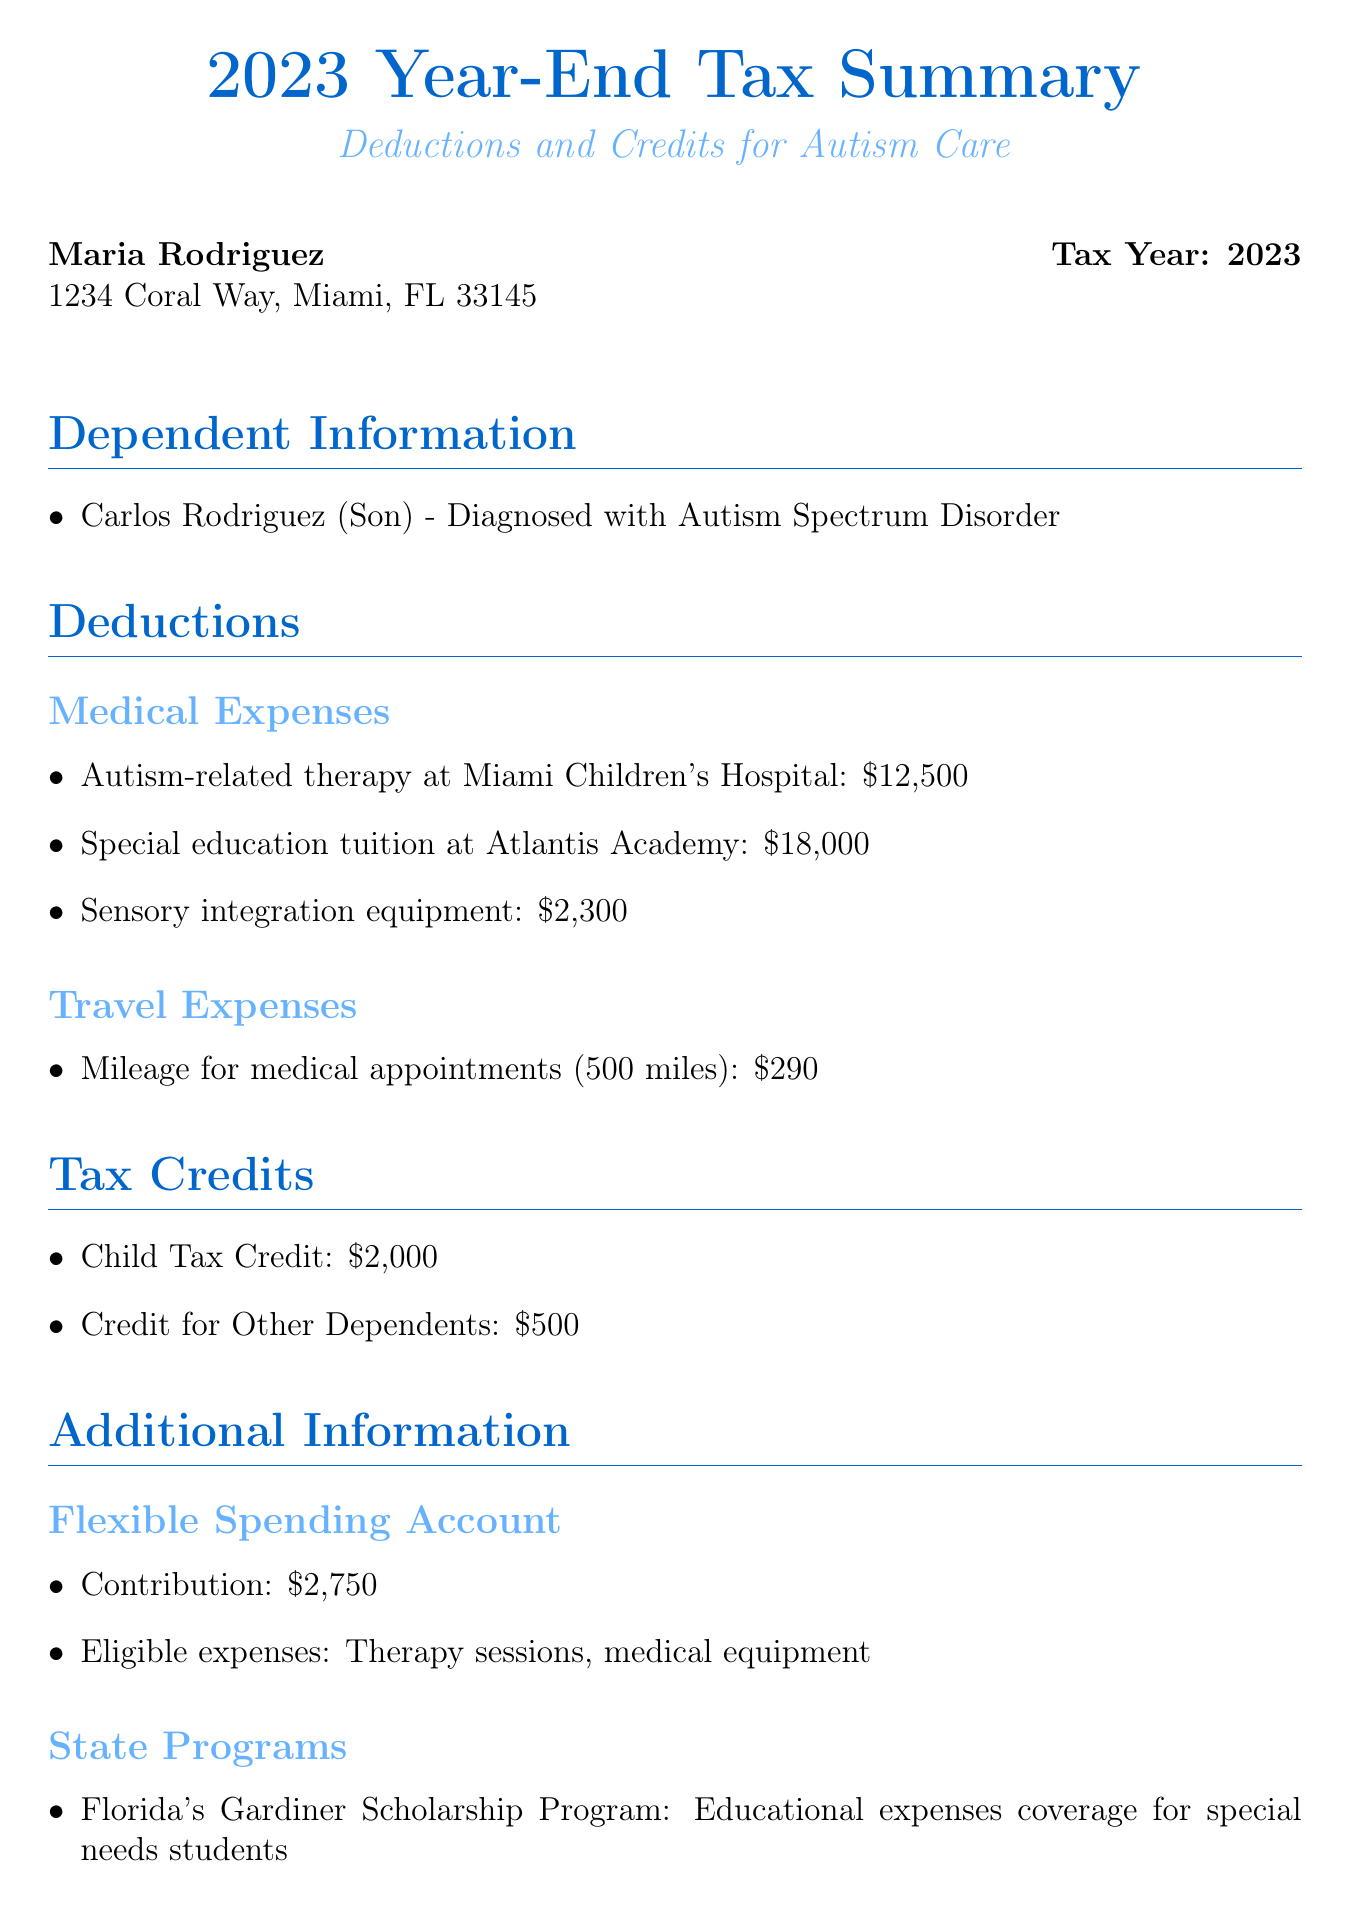What is the total amount spent on autism-related therapy? The total amount for autism-related therapy at Miami Children's Hospital is listed in the deductions section as $12,500.
Answer: $12,500 What is the contribution amount to the Flexible Spending Account? The document specifies the contribution to the Flexible Spending Account under Additional Information as $2,750.
Answer: $2,750 Who is the tax preparer? The tax preparer's name is provided at the bottom of the document, showing Johnson & Associates Tax Services.
Answer: Johnson & Associates Tax Services What is the diagnosis of Carlos Rodriguez? The diagnosis for Carlos Rodriguez is stated as Autism Spectrum Disorder in the Dependent Information section.
Answer: Autism Spectrum Disorder What is the total from the Travel Expenses category? The only item in the Travel Expenses is the mileage for medical appointments, which amounts to $290. This is the total.
Answer: $290 How much is the Child Tax Credit? The amount for the Child Tax Credit is noted in the Tax Credits section as $2,000.
Answer: $2,000 What educational expenses are covered under Florida's Gardiner Scholarship Program? The document mentions that it covers educational expenses for special needs students, specifically under State Programs.
Answer: Educational expenses for special needs students What is the total for Special Education tuition? The amount provided for Special Education tuition at Atlantis Academy is $18,000, found under Medical Expenses.
Answer: $18,000 What type of equipment is mentioned as a deduction? The document lists sensory integration equipment as an item under Medical Expenses that can be deducted.
Answer: Sensory integration equipment 